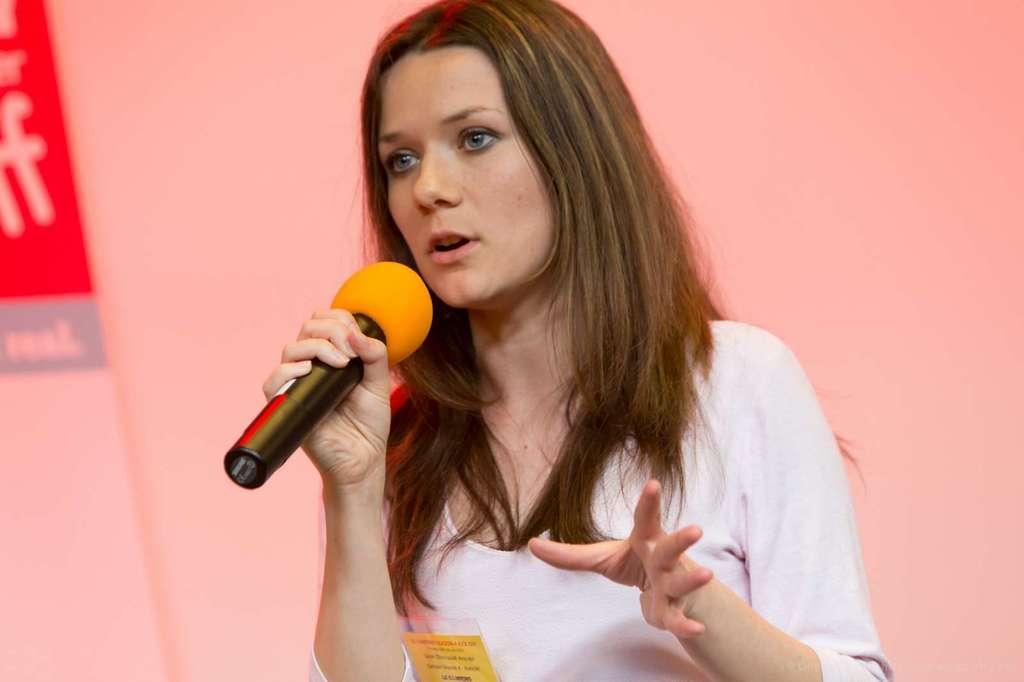Can you describe this image briefly? In this picture there is a woman holding a microphone in her right hand and speaking 